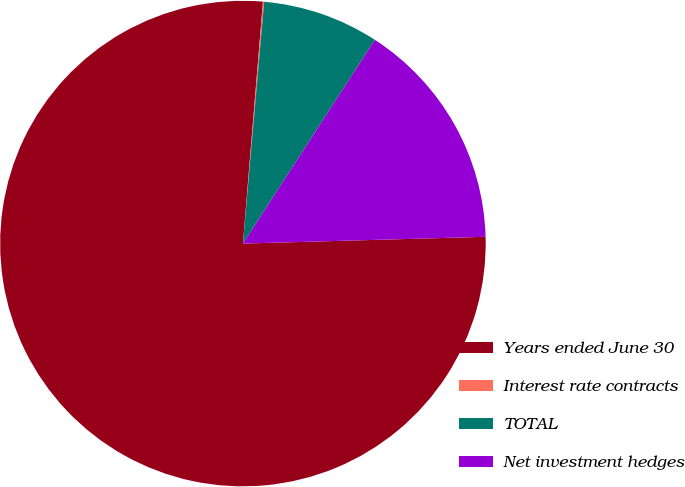Convert chart. <chart><loc_0><loc_0><loc_500><loc_500><pie_chart><fcel>Years ended June 30<fcel>Interest rate contracts<fcel>TOTAL<fcel>Net investment hedges<nl><fcel>76.76%<fcel>0.08%<fcel>7.75%<fcel>15.41%<nl></chart> 